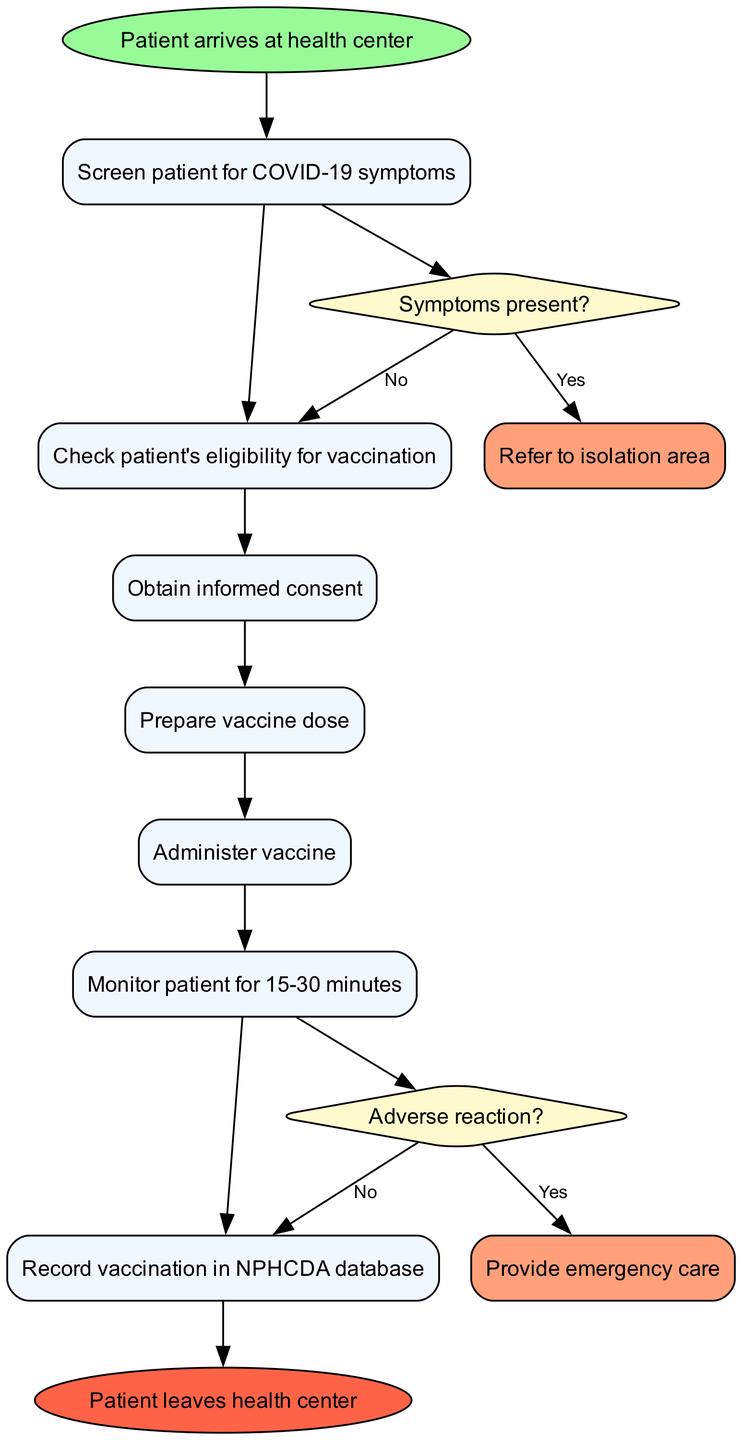What is the starting point of the procedure? The starting point node in the diagram indicates where the procedure begins, which is "Patient arrives at health center."
Answer: Patient arrives at health center How many steps are included in the vaccination procedure? By counting the steps listed in the diagram, there are a total of seven steps provided between the start and end nodes.
Answer: 7 What happens if symptoms are present during the screening? The diagram shows that if symptoms are present, the decision node leads to the action "Refer to isolation area," indicating the protocol for symptomatic patients.
Answer: Refer to isolation area What is the final step before the patient leaves the health center? The end node in the diagram indicates that after recording the vaccination, the final action is the patient leaving, as depicted clearly in the flow.
Answer: Patient leaves health center In which step is the vaccine actually administered? According to the sequential flow of the diagram, the vaccine is administered in step five, identified as "Administer vaccine."
Answer: Administer vaccine What action is taken if there is an adverse reaction after vaccine administration? The diagram specifies that an adverse reaction leads to the provision of "Provide emergency care," according to the decision node encountered after monitoring the patient.
Answer: Provide emergency care What does the diagram suggest happens after obtaining informed consent? After obtaining informed consent, the flow continues to prepare the vaccine dose, indicating the next logical step in the vaccination process following consent.
Answer: Prepare vaccine dose What step follows the monitoring of the patient? The diagram outlines that recording vaccination in the NPHCDA database follows after the patient has been monitored for 15-30 minutes.
Answer: Record vaccination in NPHCDA database 